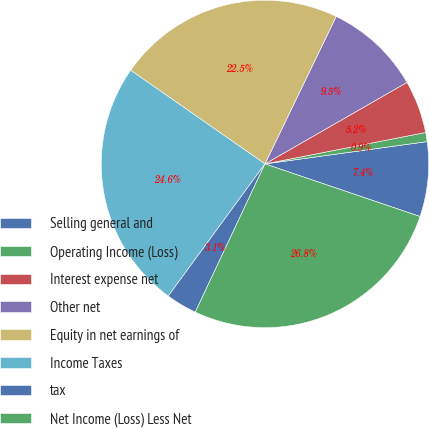Convert chart to OTSL. <chart><loc_0><loc_0><loc_500><loc_500><pie_chart><fcel>Selling general and<fcel>Operating Income (Loss)<fcel>Interest expense net<fcel>Other net<fcel>Equity in net earnings of<fcel>Income Taxes<fcel>tax<fcel>Net Income (Loss) Less Net<nl><fcel>7.38%<fcel>0.9%<fcel>5.22%<fcel>9.54%<fcel>22.47%<fcel>24.63%<fcel>3.06%<fcel>26.79%<nl></chart> 